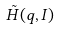<formula> <loc_0><loc_0><loc_500><loc_500>\tilde { H } ( q , I )</formula> 